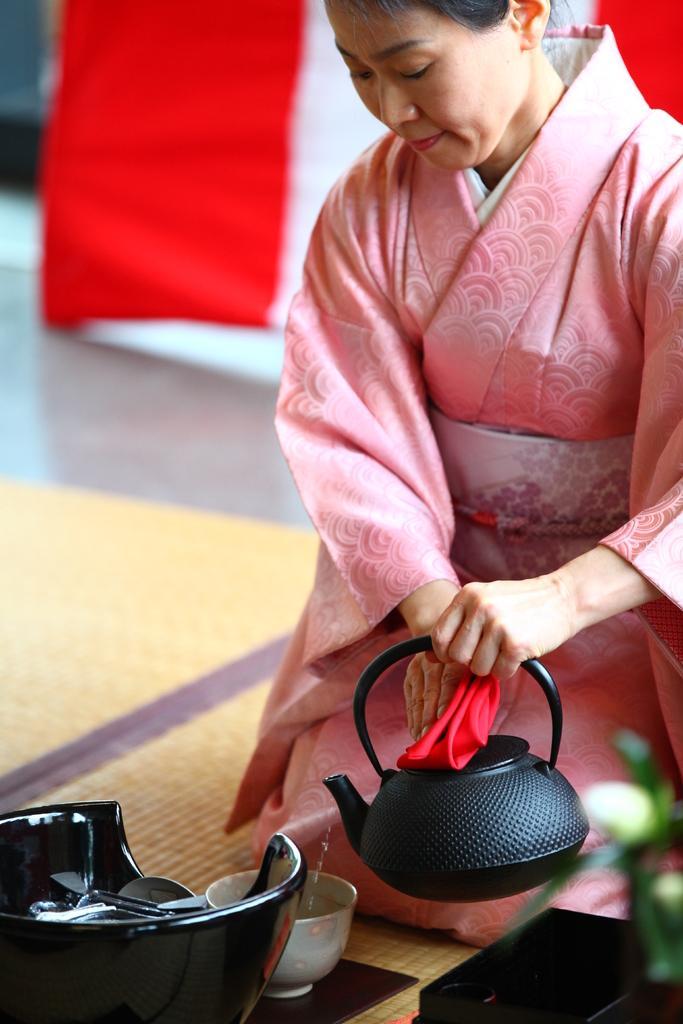Please provide a concise description of this image. This image is taken indoors. At the bottom of the image there is a floor with a mat. On the right side of the image a woman is sitting on the mat and she is holding a kettle in her hands. There is a bowl and a few things on the floor. In the background there is a curtain. 